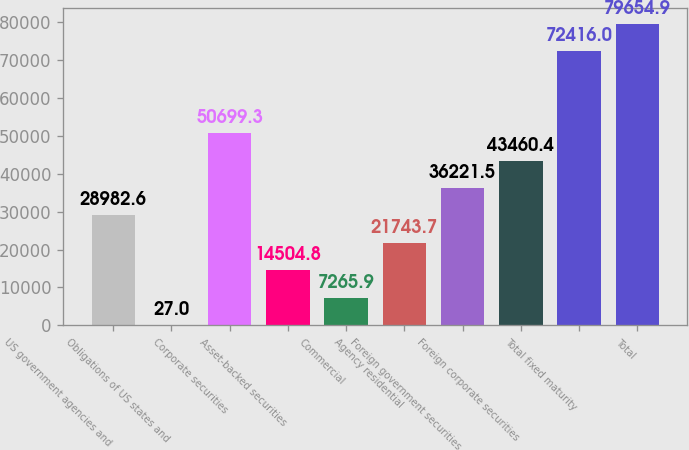Convert chart to OTSL. <chart><loc_0><loc_0><loc_500><loc_500><bar_chart><fcel>US government agencies and<fcel>Obligations of US states and<fcel>Corporate securities<fcel>Asset-backed securities<fcel>Commercial<fcel>Agency residential<fcel>Foreign government securities<fcel>Foreign corporate securities<fcel>Total fixed maturity<fcel>Total<nl><fcel>28982.6<fcel>27<fcel>50699.3<fcel>14504.8<fcel>7265.9<fcel>21743.7<fcel>36221.5<fcel>43460.4<fcel>72416<fcel>79654.9<nl></chart> 